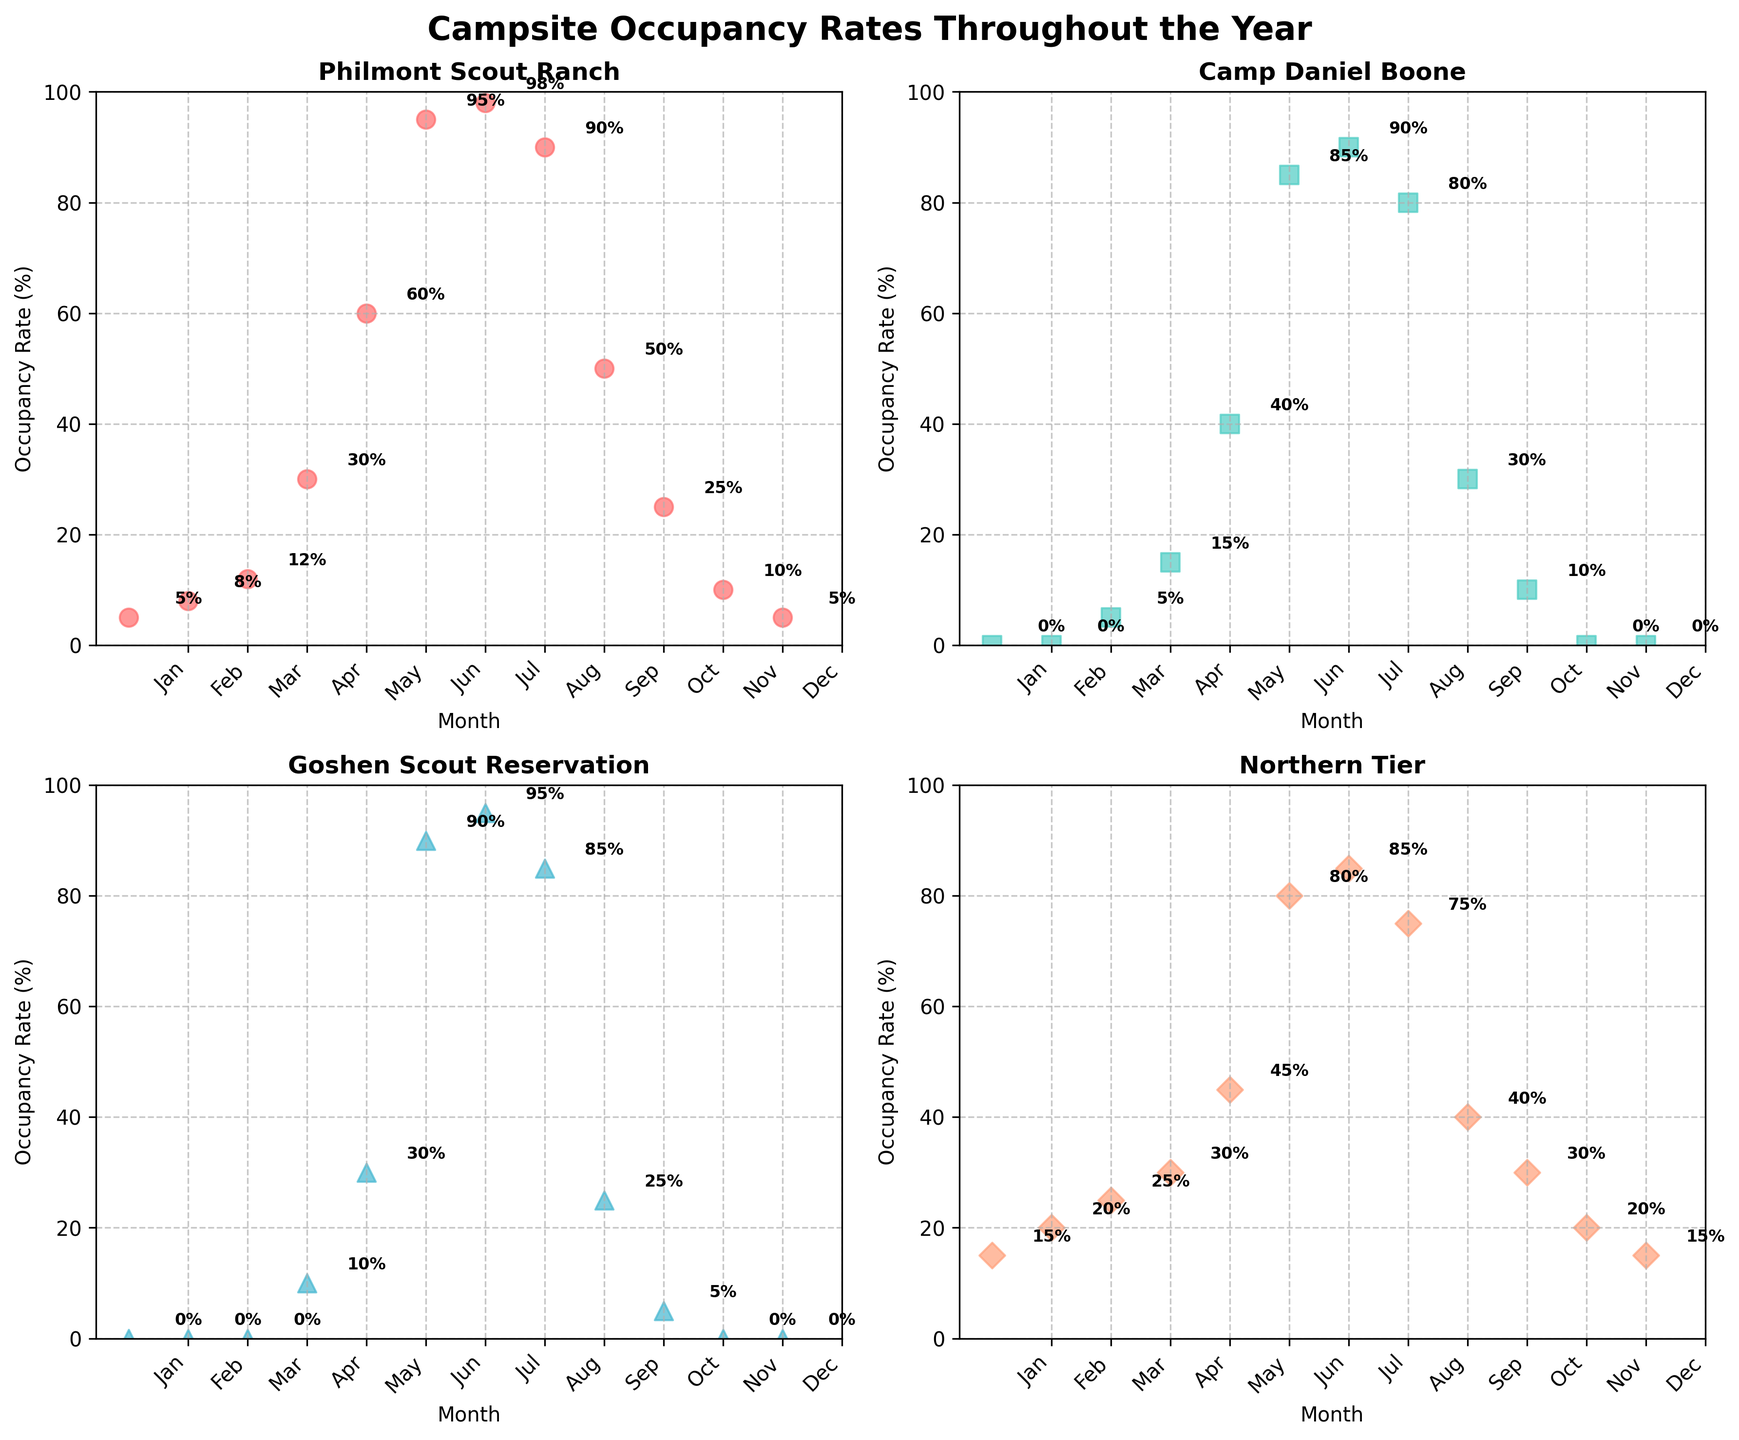What's the maximum occupancy rate at Philmont Scout Ranch? The scatter plot for Philmont Scout Ranch shows the highest point in the month of July, where the occupancy rate reaches 98%.
Answer: 98% Which campsite has the highest occupancy rate in March? By looking at the scatter plots of all sites for March, Northern Tier has an occupancy rate of 25%, which is higher than the others.
Answer: Northern Tier In which two months does Philmont Scout Ranch have an occupancy rate of exactly 5%? Observing the scatter plot for Philmont Scout Ranch shows dots labeled 5% in the months of January and December.
Answer: January and December During which month does Northern Tier have an occupancy rate of 80%? For Northern Tier, the scatter plot indicates an 80% occupancy rate in June.
Answer: June What's the average occupancy rate for Camp Daniel Boone in summer months (June, July, August)? The occupancy rates for June, July, and August at Camp Daniel Boone are 85%, 90%, and 80%, respectively. The average is calculated as (85+90+80)/3 = 85%.
Answer: 85% Compare the occupancy rates of Goshen Scout Reservation in April and October. Which month has a higher rate and by how much? In April, Goshen Scout Reservation has an occupancy rate of 10%, while in October, it is 5%. The difference is 10% - 5% = 5%, with April being higher.
Answer: April by 5% Which month shows the highest difference in occupancy rates between Philmont Scout Ranch and Northern Tier, and what is the difference? To find the highest difference, look at each month's rates and subtract them. July has the highest difference: Philmont Scout Ranch is 98% and Northern Tier is 85%. The difference is 98% - 85% = 13%.
Answer: July, 13% From the scatter plots, during which months does Camp Daniel Boone have an occupancy rate of 0%? The scatter plot for Camp Daniel Boone indicates an occupancy rate of 0% in January, February, November, and December.
Answer: January, February, November, December What's the total occupancy rate for Philmont Scout Ranch from January to March combined? Summing up the occupancy rates from January to March for Philmont Scout Ranch: 5% (Jan) + 8% (Feb) + 12% (Mar) = 25%.
Answer: 25% In which month does Goshen Scout Reservation first reach an occupancy rate of 25% or higher? Goshen Scout Reservation reaches an occupancy rate of 30% in May, which is the first month meeting the criterion.
Answer: May 